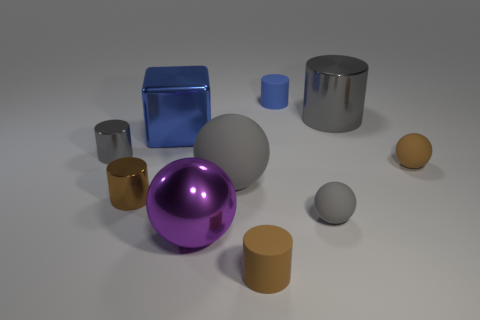Subtract all gray spheres. How many brown cylinders are left? 2 Subtract 3 cylinders. How many cylinders are left? 2 Subtract all brown spheres. How many spheres are left? 3 Subtract all small brown spheres. How many spheres are left? 3 Subtract all yellow spheres. Subtract all blue cubes. How many spheres are left? 4 Subtract all cubes. How many objects are left? 9 Add 2 large purple things. How many large purple things exist? 3 Subtract 0 gray cubes. How many objects are left? 10 Subtract all tiny green blocks. Subtract all tiny blue rubber cylinders. How many objects are left? 9 Add 6 spheres. How many spheres are left? 10 